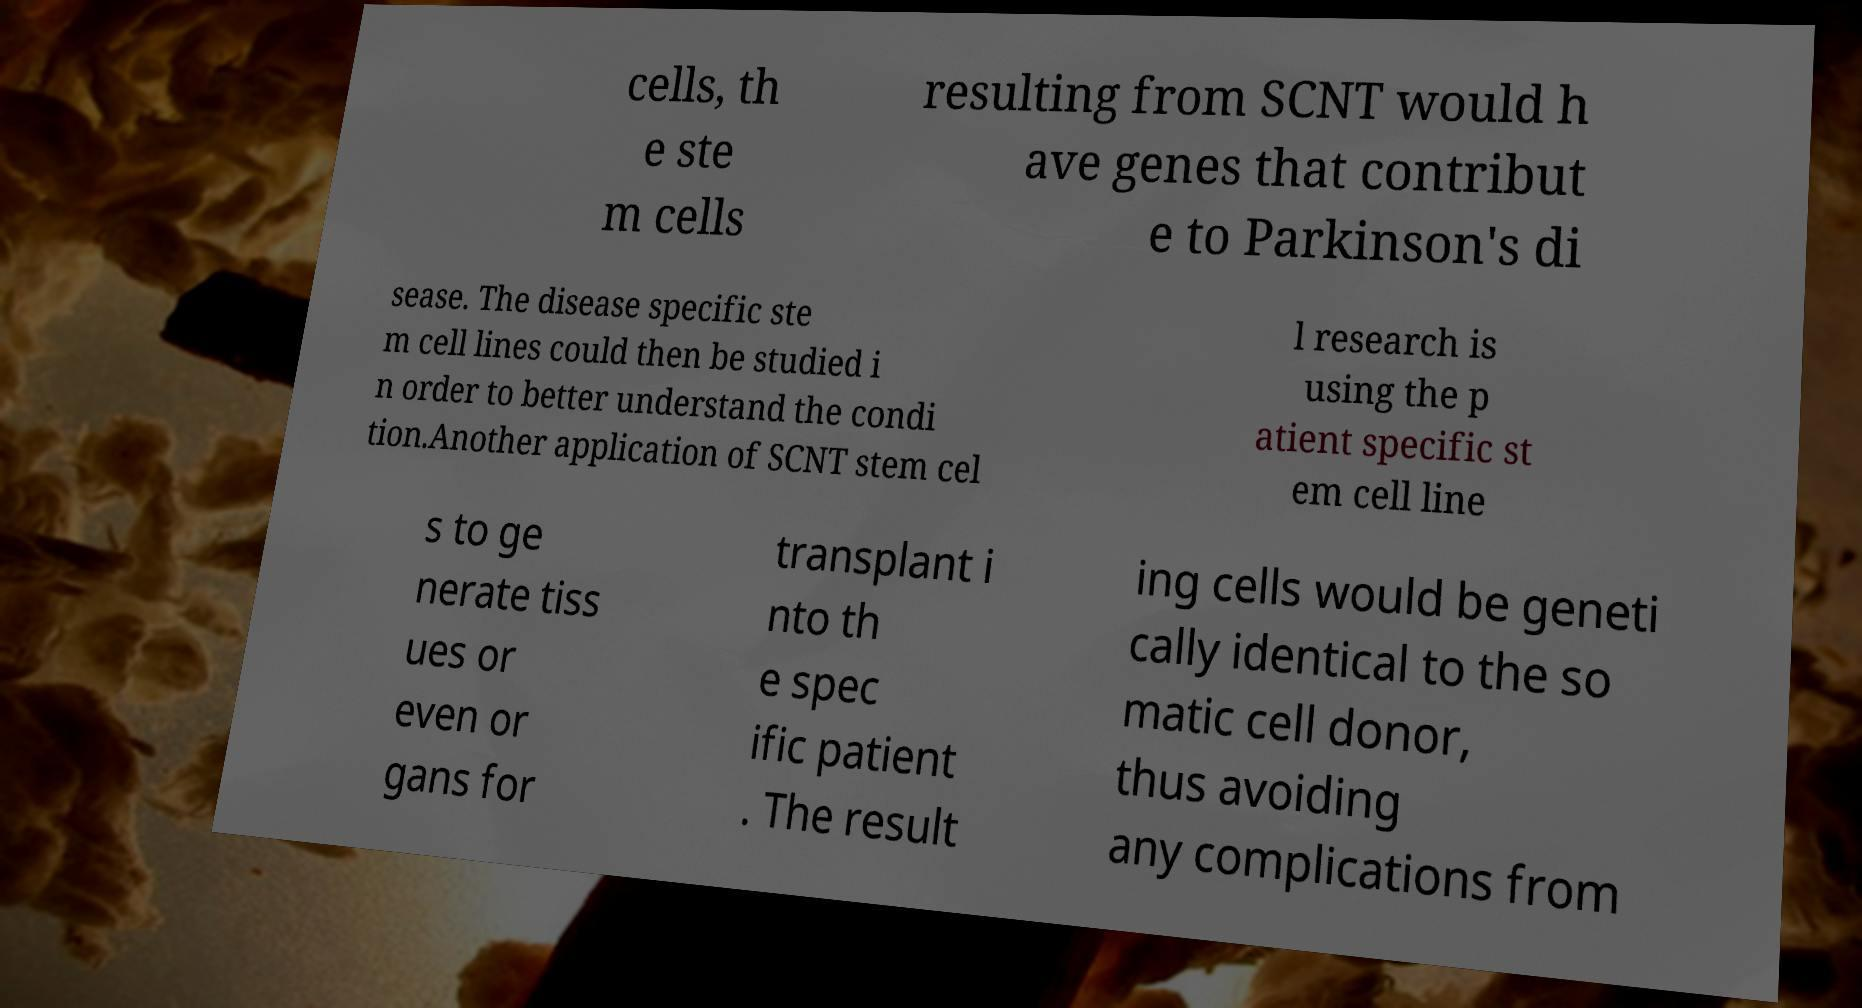Please read and relay the text visible in this image. What does it say? cells, th e ste m cells resulting from SCNT would h ave genes that contribut e to Parkinson's di sease. The disease specific ste m cell lines could then be studied i n order to better understand the condi tion.Another application of SCNT stem cel l research is using the p atient specific st em cell line s to ge nerate tiss ues or even or gans for transplant i nto th e spec ific patient . The result ing cells would be geneti cally identical to the so matic cell donor, thus avoiding any complications from 